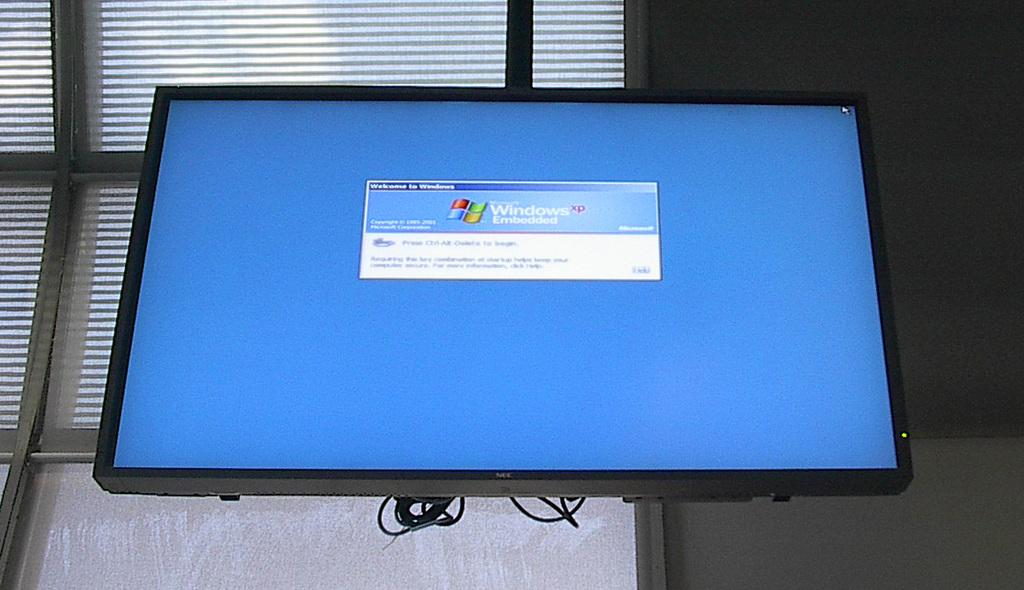<image>
Give a short and clear explanation of the subsequent image. A flat screen monitor shows a welcome screen for Windows XP Embedded. 